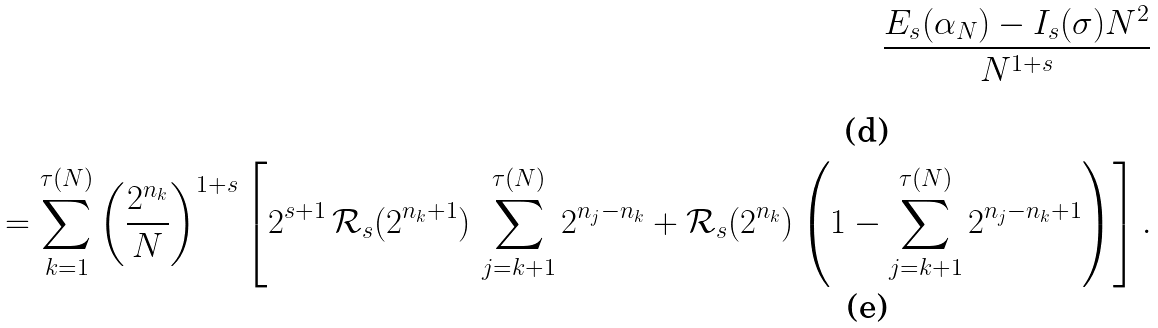<formula> <loc_0><loc_0><loc_500><loc_500>\frac { E _ { s } ( \alpha _ { N } ) - I _ { s } ( \sigma ) N ^ { 2 } } { N ^ { 1 + s } } \\ = \sum _ { k = 1 } ^ { \tau ( N ) } \left ( \frac { 2 ^ { n _ { k } } } { N } \right ) ^ { 1 + s } \left [ 2 ^ { s + 1 } \, \mathcal { R } _ { s } ( 2 ^ { n _ { k } + 1 } ) \, \sum _ { j = k + 1 } ^ { \tau ( N ) } 2 ^ { n _ { j } - n _ { k } } + \mathcal { R } _ { s } ( 2 ^ { n _ { k } } ) \left ( 1 - \sum _ { j = k + 1 } ^ { \tau ( N ) } 2 ^ { n _ { j } - n _ { k } + 1 } \right ) \right ] .</formula> 